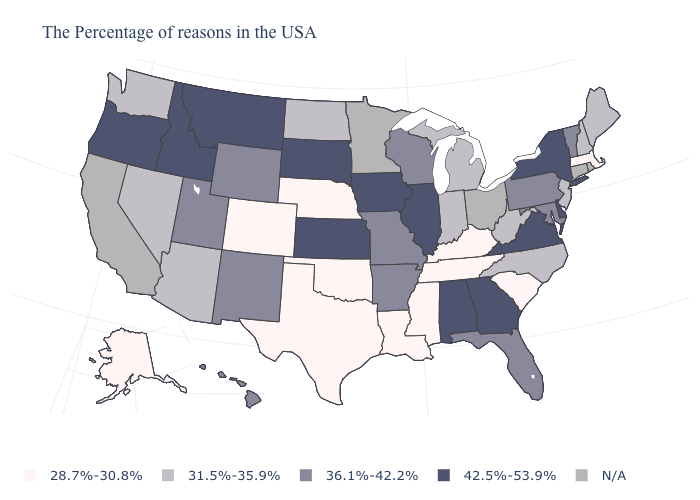Name the states that have a value in the range 28.7%-30.8%?
Be succinct. Massachusetts, South Carolina, Kentucky, Tennessee, Mississippi, Louisiana, Nebraska, Oklahoma, Texas, Colorado, Alaska. Is the legend a continuous bar?
Keep it brief. No. Among the states that border Michigan , which have the lowest value?
Write a very short answer. Indiana. Which states have the lowest value in the USA?
Keep it brief. Massachusetts, South Carolina, Kentucky, Tennessee, Mississippi, Louisiana, Nebraska, Oklahoma, Texas, Colorado, Alaska. What is the lowest value in the South?
Answer briefly. 28.7%-30.8%. Among the states that border Montana , which have the highest value?
Be succinct. South Dakota, Idaho. What is the value of Maine?
Answer briefly. 31.5%-35.9%. What is the value of Georgia?
Quick response, please. 42.5%-53.9%. Which states have the lowest value in the South?
Give a very brief answer. South Carolina, Kentucky, Tennessee, Mississippi, Louisiana, Oklahoma, Texas. What is the lowest value in states that border New York?
Write a very short answer. 28.7%-30.8%. Name the states that have a value in the range 28.7%-30.8%?
Concise answer only. Massachusetts, South Carolina, Kentucky, Tennessee, Mississippi, Louisiana, Nebraska, Oklahoma, Texas, Colorado, Alaska. What is the highest value in the USA?
Quick response, please. 42.5%-53.9%. Name the states that have a value in the range 31.5%-35.9%?
Write a very short answer. Maine, New Hampshire, New Jersey, North Carolina, West Virginia, Michigan, Indiana, North Dakota, Arizona, Nevada, Washington. 